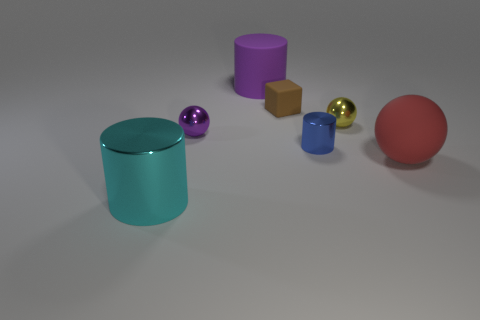Subtract all red cylinders. Subtract all brown blocks. How many cylinders are left? 3 Add 3 large purple things. How many objects exist? 10 Subtract all cylinders. How many objects are left? 4 Add 6 big purple matte things. How many big purple matte things exist? 7 Subtract 0 blue spheres. How many objects are left? 7 Subtract all tiny blue metal objects. Subtract all purple metal spheres. How many objects are left? 5 Add 1 brown blocks. How many brown blocks are left? 2 